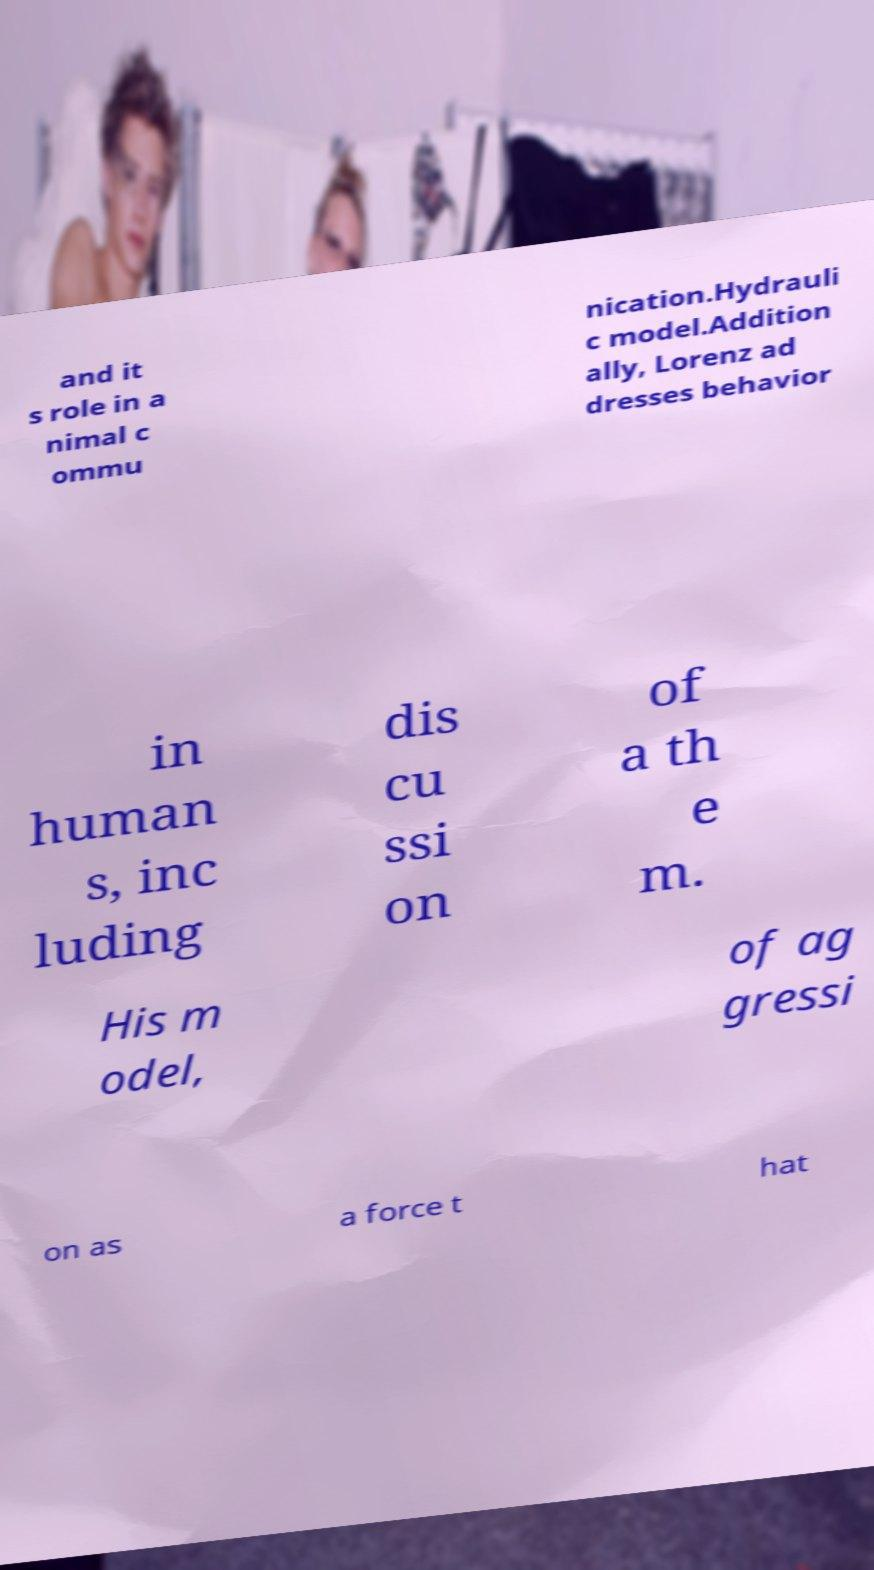What messages or text are displayed in this image? I need them in a readable, typed format. and it s role in a nimal c ommu nication.Hydrauli c model.Addition ally, Lorenz ad dresses behavior in human s, inc luding dis cu ssi on of a th e m. His m odel, of ag gressi on as a force t hat 